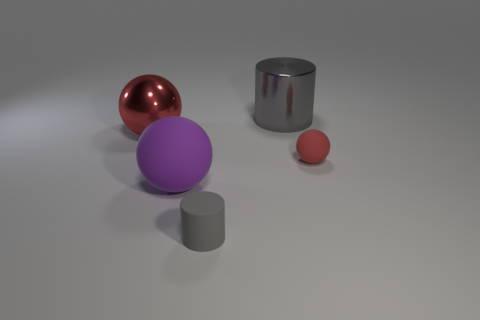How many gray cylinders must be subtracted to get 1 gray cylinders? 1 Subtract all red balls. How many balls are left? 1 Add 2 large gray things. How many objects exist? 7 Subtract all red balls. How many balls are left? 1 Subtract all balls. How many objects are left? 2 Subtract 3 balls. How many balls are left? 0 Subtract all green blocks. How many red spheres are left? 2 Subtract all green cylinders. Subtract all red blocks. How many cylinders are left? 2 Subtract all purple objects. Subtract all large yellow matte spheres. How many objects are left? 4 Add 5 tiny red objects. How many tiny red objects are left? 6 